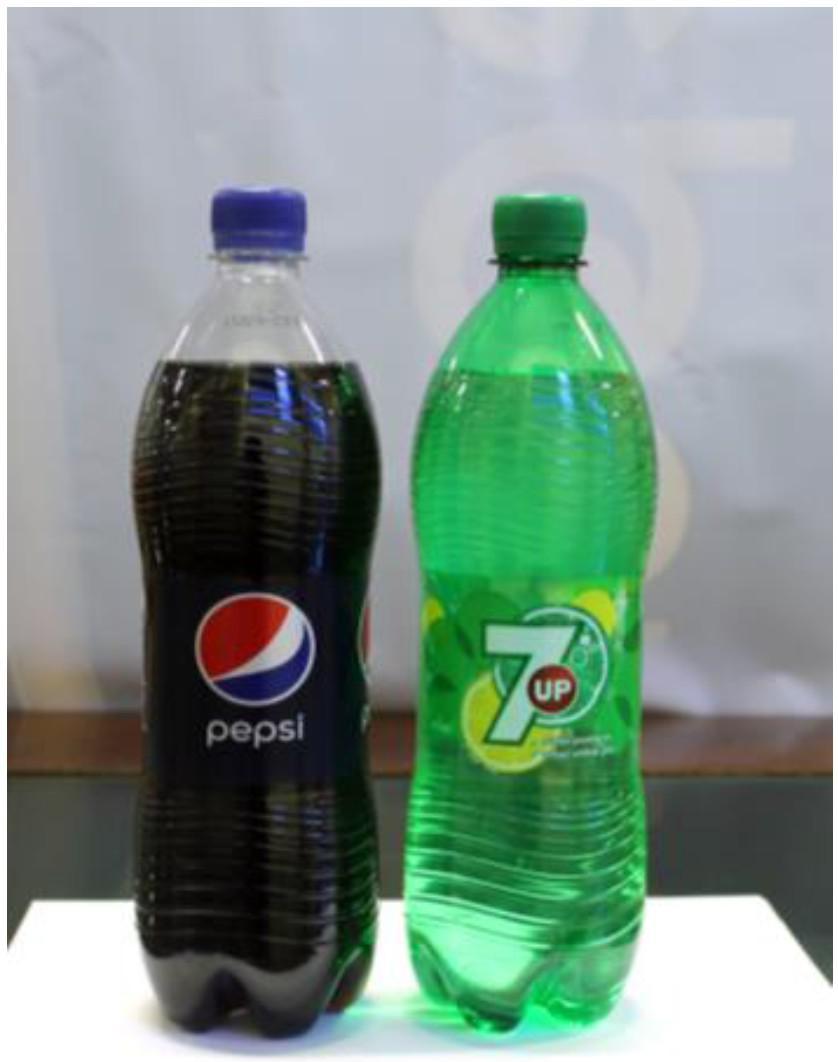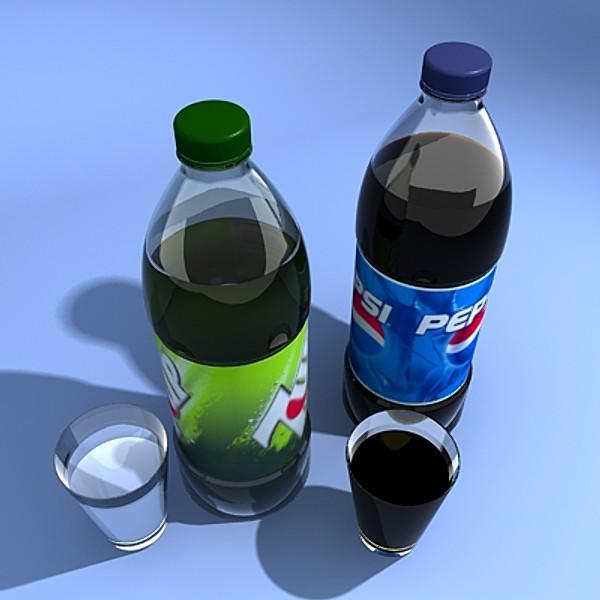The first image is the image on the left, the second image is the image on the right. Examine the images to the left and right. Is the description "In the left image there are exactly two bottles with soda in them." accurate? Answer yes or no. Yes. The first image is the image on the left, the second image is the image on the right. Given the left and right images, does the statement "There are two glass full of the liquad from the soda bottle behind them." hold true? Answer yes or no. Yes. 